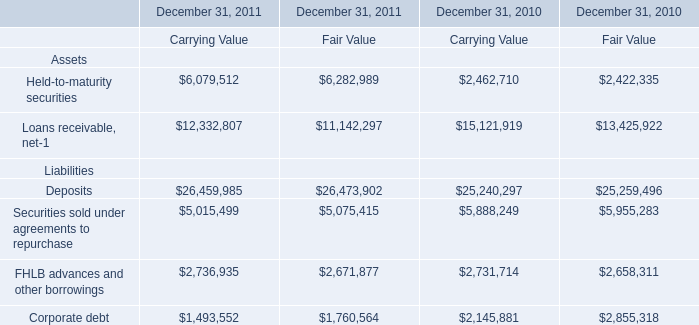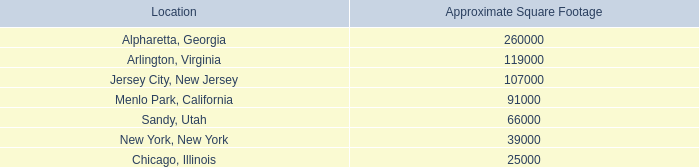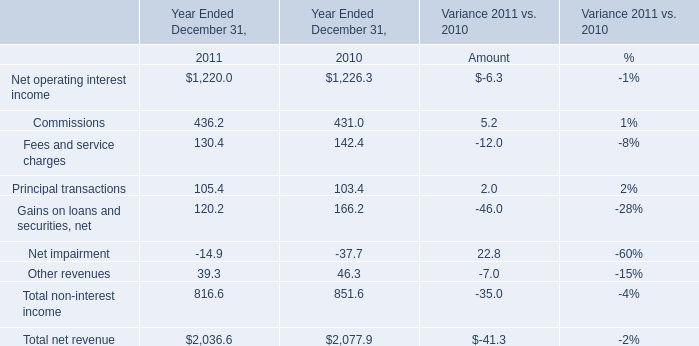as of december 31 , 2011 what was the percent of space not leased space in alpharetta , georgia . 
Computations: (165000 / 260000)
Answer: 0.63462. 